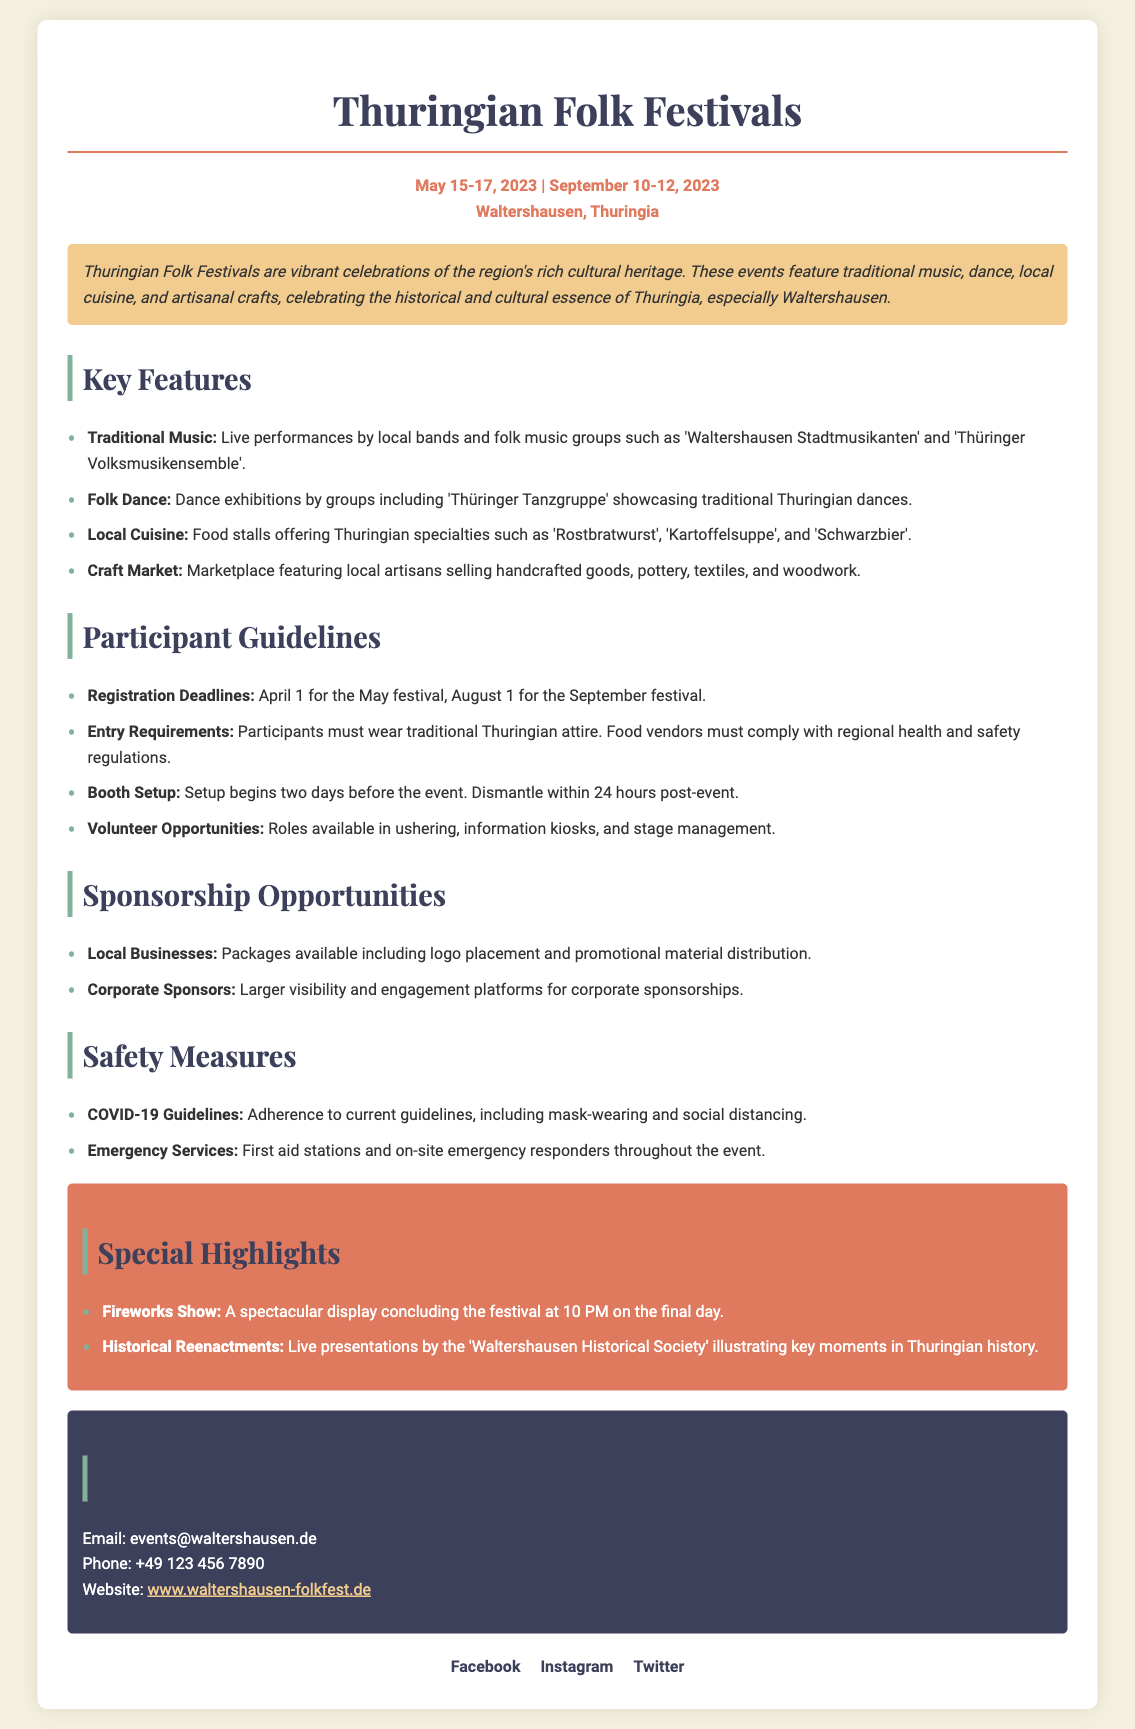What is the contact email for the events? The contact information section provides an email address for inquiries related to the events.
Answer: events@waltershausen.de What is a traditional food offered at the festivals? The document lists local cuisine items featured at the festivals, including specific Thuringian specialties.
Answer: Rostbratwurst What are the entry requirements for participants? The guidelines outline specific conditions participants must meet to join the event.
Answer: Traditional Thuringian attire What is one of the special highlights of the festival? The special highlights section includes unique features that enhance the event experience.
Answer: Fireworks Show When is the booth setup allowed? The participant guidelines state when vendors can prepare their booths before the event.
Answer: Two days before the event How many festival days are there in total? The document states the number of days each festival runs, allowing for quick arithmetic to determine the total.
Answer: Three days What type of sponsorship opportunities are mentioned? The document indicates options for sponsorship for both local businesses and corporate sponsors.
Answer: Local Businesses, Corporate Sponsors What does the overview emphasize about the festivals? The overview provides a summary of the cultural significance of the festivals in the region.
Answer: Cultural heritage 